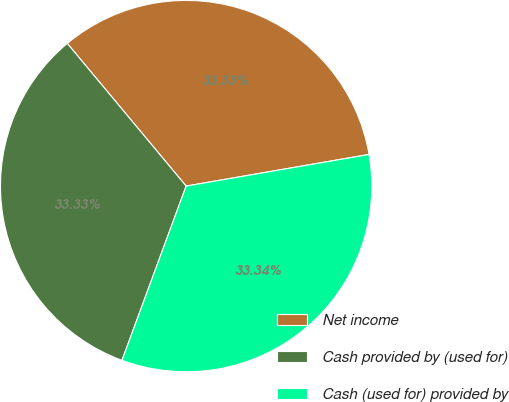<chart> <loc_0><loc_0><loc_500><loc_500><pie_chart><fcel>Net income<fcel>Cash provided by (used for)<fcel>Cash (used for) provided by<nl><fcel>33.33%<fcel>33.33%<fcel>33.34%<nl></chart> 